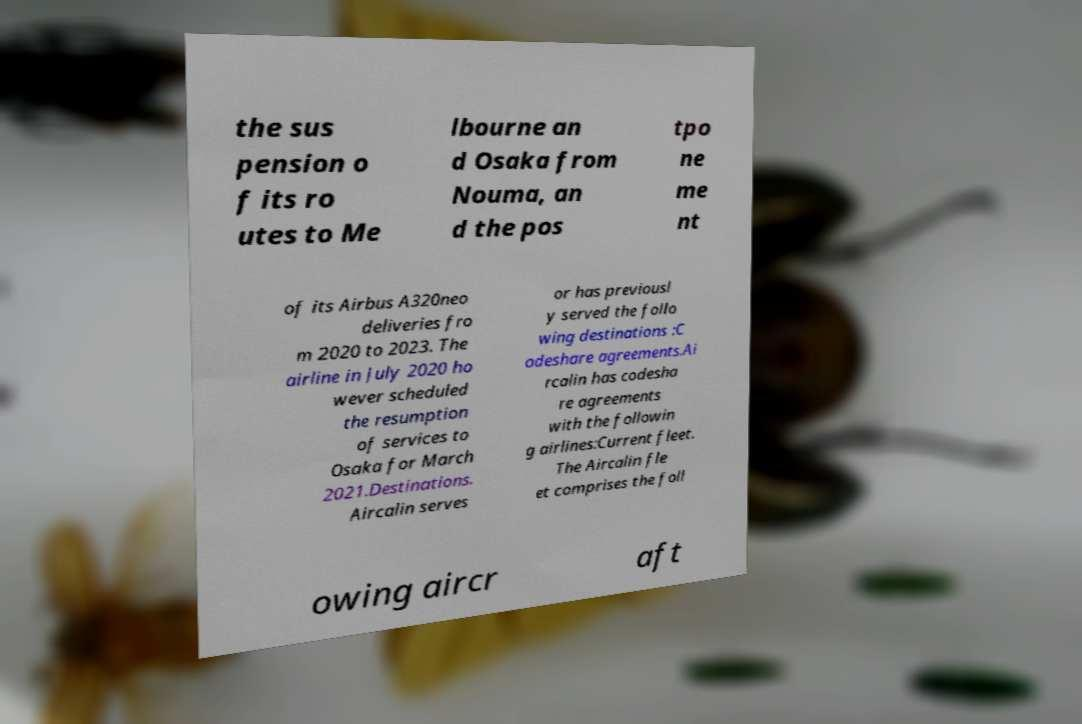There's text embedded in this image that I need extracted. Can you transcribe it verbatim? the sus pension o f its ro utes to Me lbourne an d Osaka from Nouma, an d the pos tpo ne me nt of its Airbus A320neo deliveries fro m 2020 to 2023. The airline in July 2020 ho wever scheduled the resumption of services to Osaka for March 2021.Destinations. Aircalin serves or has previousl y served the follo wing destinations :C odeshare agreements.Ai rcalin has codesha re agreements with the followin g airlines:Current fleet. The Aircalin fle et comprises the foll owing aircr aft 